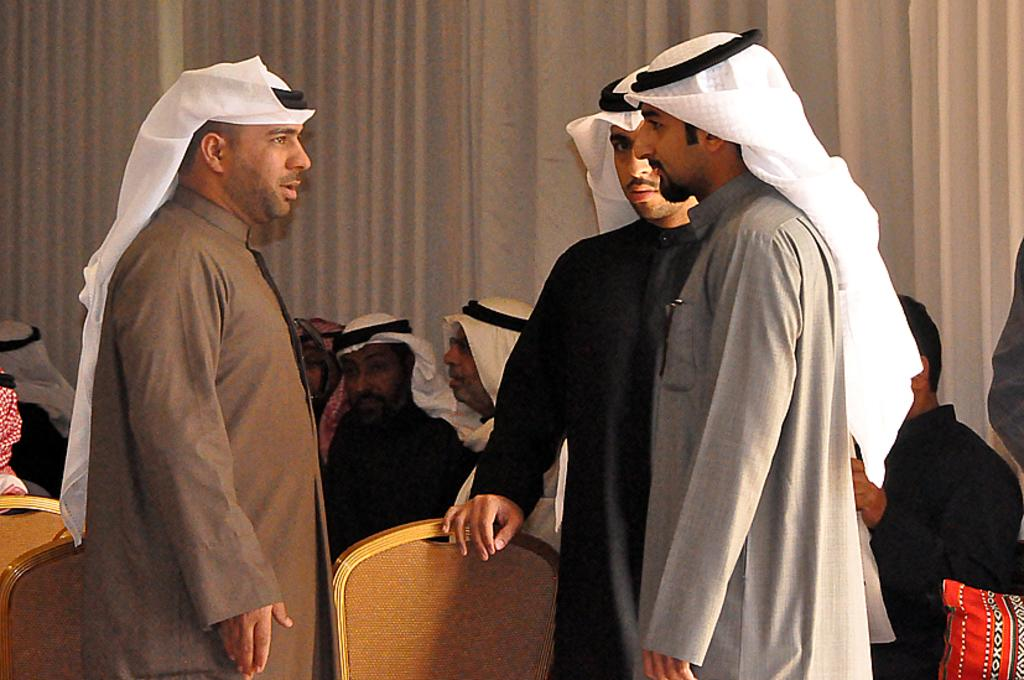How many men are standing in the image? There are three men standing in the image. What are the people behind the men doing? The people behind the men are sitting. What color is the curtain visible in the image? The curtain is white-colored. What type of lunch is being served on the desk in the image? There is no desk or lunch present in the image. How many clocks can be seen hanging on the wall in the image? There are no clocks visible in the image. 